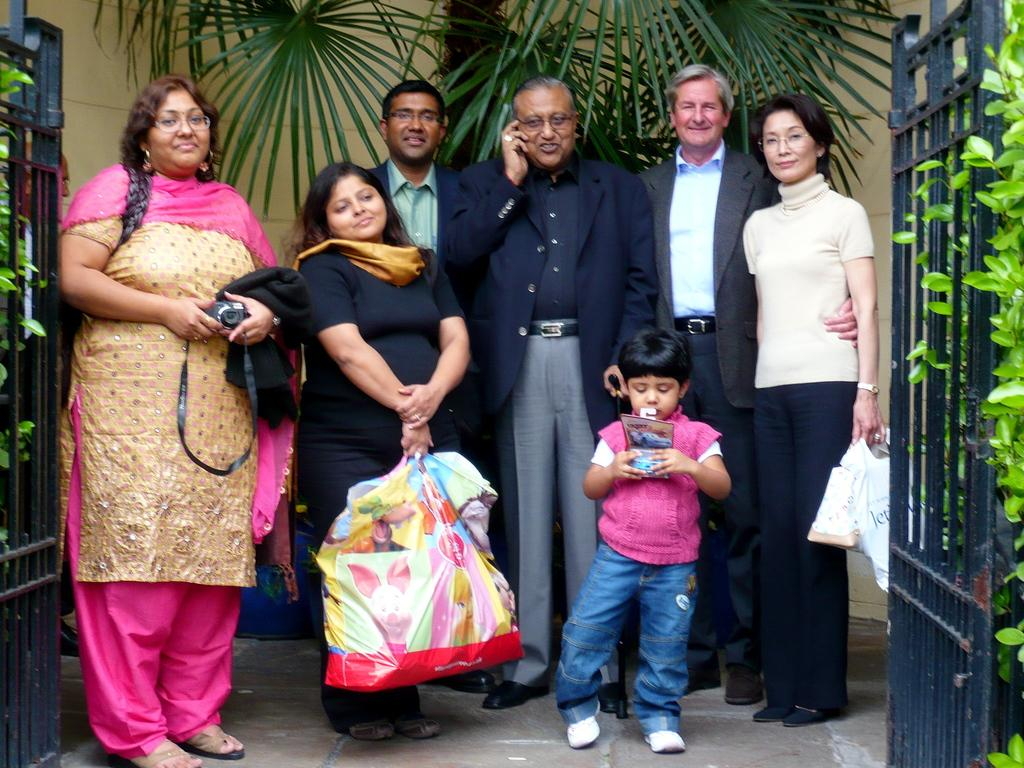How many people are in the image? There is a group of people in the image, but the exact number is not specified. What are the people in the image doing? Some people are smiling, and some are holding objects. What type of objects are the people holding? The objects held by the people are not specified. What can be seen in the image besides people? There are plants, grills, a tree, and a wall in the background of the image. What type of steel is used to construct the baseball in the image? There is no baseball present in the image, and therefore no steel can be associated with it. 